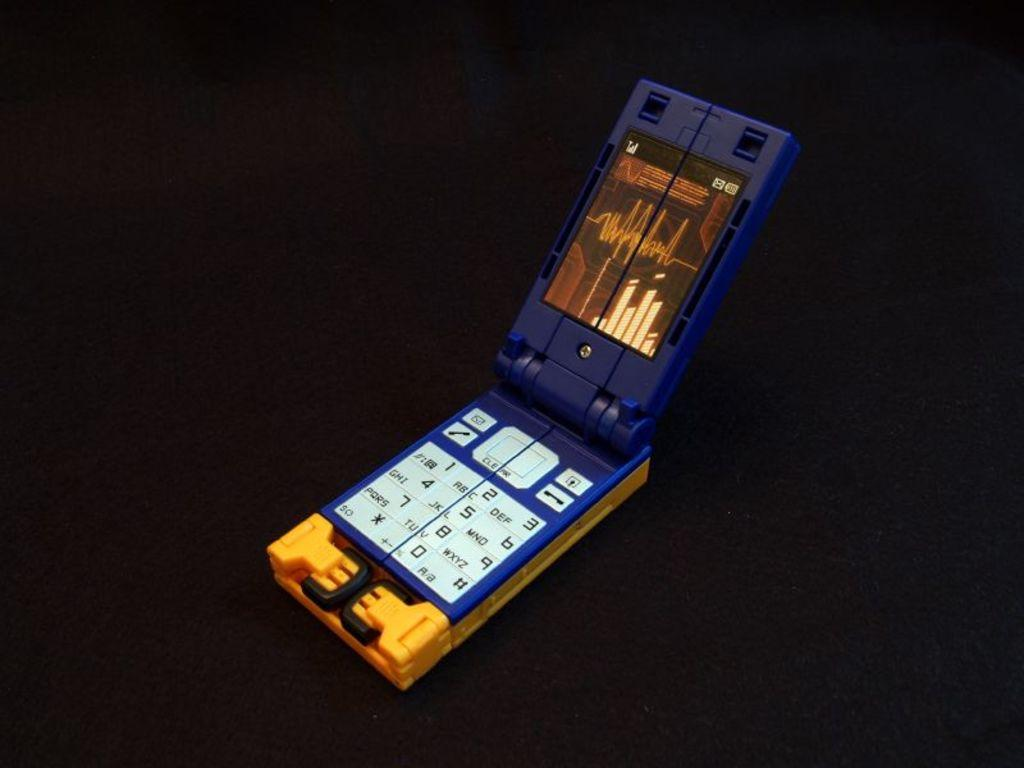<image>
Provide a brief description of the given image. open flip phone that looks like its made of legos, only lettering on it is word clear, numbers 0-9 and a-z 